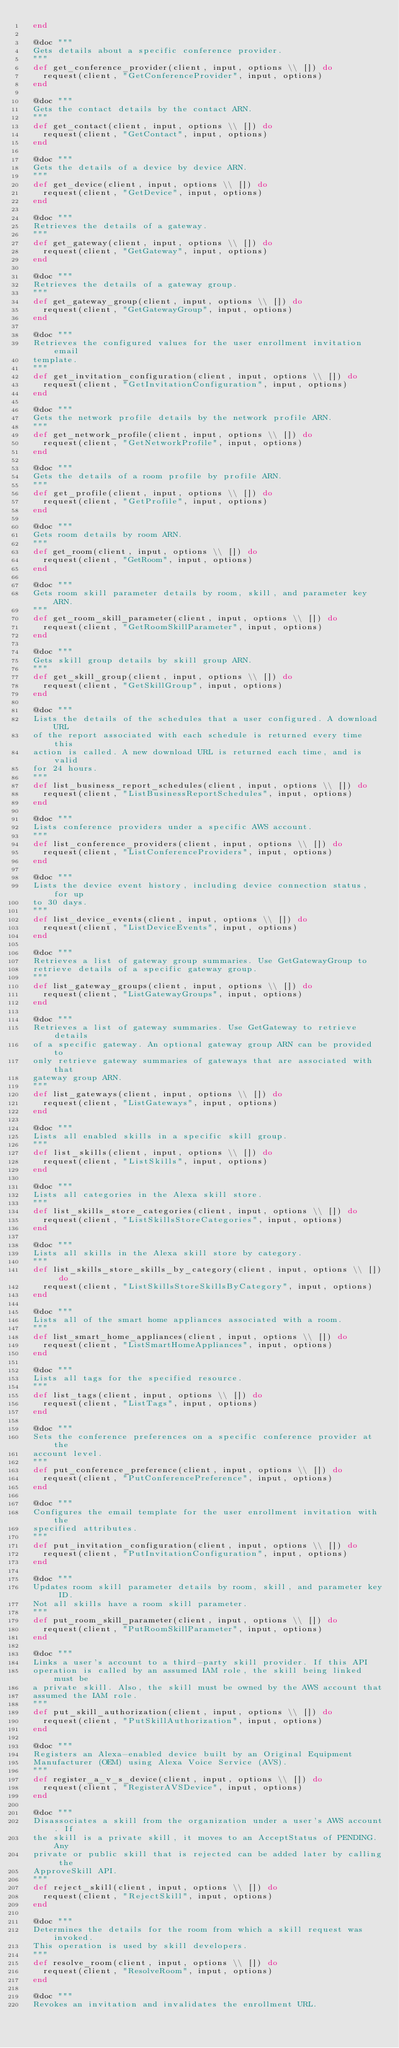Convert code to text. <code><loc_0><loc_0><loc_500><loc_500><_Elixir_>  end

  @doc """
  Gets details about a specific conference provider.
  """
  def get_conference_provider(client, input, options \\ []) do
    request(client, "GetConferenceProvider", input, options)
  end

  @doc """
  Gets the contact details by the contact ARN.
  """
  def get_contact(client, input, options \\ []) do
    request(client, "GetContact", input, options)
  end

  @doc """
  Gets the details of a device by device ARN.
  """
  def get_device(client, input, options \\ []) do
    request(client, "GetDevice", input, options)
  end

  @doc """
  Retrieves the details of a gateway.
  """
  def get_gateway(client, input, options \\ []) do
    request(client, "GetGateway", input, options)
  end

  @doc """
  Retrieves the details of a gateway group.
  """
  def get_gateway_group(client, input, options \\ []) do
    request(client, "GetGatewayGroup", input, options)
  end

  @doc """
  Retrieves the configured values for the user enrollment invitation email
  template.
  """
  def get_invitation_configuration(client, input, options \\ []) do
    request(client, "GetInvitationConfiguration", input, options)
  end

  @doc """
  Gets the network profile details by the network profile ARN.
  """
  def get_network_profile(client, input, options \\ []) do
    request(client, "GetNetworkProfile", input, options)
  end

  @doc """
  Gets the details of a room profile by profile ARN.
  """
  def get_profile(client, input, options \\ []) do
    request(client, "GetProfile", input, options)
  end

  @doc """
  Gets room details by room ARN.
  """
  def get_room(client, input, options \\ []) do
    request(client, "GetRoom", input, options)
  end

  @doc """
  Gets room skill parameter details by room, skill, and parameter key ARN.
  """
  def get_room_skill_parameter(client, input, options \\ []) do
    request(client, "GetRoomSkillParameter", input, options)
  end

  @doc """
  Gets skill group details by skill group ARN.
  """
  def get_skill_group(client, input, options \\ []) do
    request(client, "GetSkillGroup", input, options)
  end

  @doc """
  Lists the details of the schedules that a user configured. A download URL
  of the report associated with each schedule is returned every time this
  action is called. A new download URL is returned each time, and is valid
  for 24 hours.
  """
  def list_business_report_schedules(client, input, options \\ []) do
    request(client, "ListBusinessReportSchedules", input, options)
  end

  @doc """
  Lists conference providers under a specific AWS account.
  """
  def list_conference_providers(client, input, options \\ []) do
    request(client, "ListConferenceProviders", input, options)
  end

  @doc """
  Lists the device event history, including device connection status, for up
  to 30 days.
  """
  def list_device_events(client, input, options \\ []) do
    request(client, "ListDeviceEvents", input, options)
  end

  @doc """
  Retrieves a list of gateway group summaries. Use GetGatewayGroup to
  retrieve details of a specific gateway group.
  """
  def list_gateway_groups(client, input, options \\ []) do
    request(client, "ListGatewayGroups", input, options)
  end

  @doc """
  Retrieves a list of gateway summaries. Use GetGateway to retrieve details
  of a specific gateway. An optional gateway group ARN can be provided to
  only retrieve gateway summaries of gateways that are associated with that
  gateway group ARN.
  """
  def list_gateways(client, input, options \\ []) do
    request(client, "ListGateways", input, options)
  end

  @doc """
  Lists all enabled skills in a specific skill group.
  """
  def list_skills(client, input, options \\ []) do
    request(client, "ListSkills", input, options)
  end

  @doc """
  Lists all categories in the Alexa skill store.
  """
  def list_skills_store_categories(client, input, options \\ []) do
    request(client, "ListSkillsStoreCategories", input, options)
  end

  @doc """
  Lists all skills in the Alexa skill store by category.
  """
  def list_skills_store_skills_by_category(client, input, options \\ []) do
    request(client, "ListSkillsStoreSkillsByCategory", input, options)
  end

  @doc """
  Lists all of the smart home appliances associated with a room.
  """
  def list_smart_home_appliances(client, input, options \\ []) do
    request(client, "ListSmartHomeAppliances", input, options)
  end

  @doc """
  Lists all tags for the specified resource.
  """
  def list_tags(client, input, options \\ []) do
    request(client, "ListTags", input, options)
  end

  @doc """
  Sets the conference preferences on a specific conference provider at the
  account level.
  """
  def put_conference_preference(client, input, options \\ []) do
    request(client, "PutConferencePreference", input, options)
  end

  @doc """
  Configures the email template for the user enrollment invitation with the
  specified attributes.
  """
  def put_invitation_configuration(client, input, options \\ []) do
    request(client, "PutInvitationConfiguration", input, options)
  end

  @doc """
  Updates room skill parameter details by room, skill, and parameter key ID.
  Not all skills have a room skill parameter.
  """
  def put_room_skill_parameter(client, input, options \\ []) do
    request(client, "PutRoomSkillParameter", input, options)
  end

  @doc """
  Links a user's account to a third-party skill provider. If this API
  operation is called by an assumed IAM role, the skill being linked must be
  a private skill. Also, the skill must be owned by the AWS account that
  assumed the IAM role.
  """
  def put_skill_authorization(client, input, options \\ []) do
    request(client, "PutSkillAuthorization", input, options)
  end

  @doc """
  Registers an Alexa-enabled device built by an Original Equipment
  Manufacturer (OEM) using Alexa Voice Service (AVS).
  """
  def register_a_v_s_device(client, input, options \\ []) do
    request(client, "RegisterAVSDevice", input, options)
  end

  @doc """
  Disassociates a skill from the organization under a user's AWS account. If
  the skill is a private skill, it moves to an AcceptStatus of PENDING. Any
  private or public skill that is rejected can be added later by calling the
  ApproveSkill API.
  """
  def reject_skill(client, input, options \\ []) do
    request(client, "RejectSkill", input, options)
  end

  @doc """
  Determines the details for the room from which a skill request was invoked.
  This operation is used by skill developers.
  """
  def resolve_room(client, input, options \\ []) do
    request(client, "ResolveRoom", input, options)
  end

  @doc """
  Revokes an invitation and invalidates the enrollment URL.</code> 